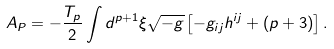<formula> <loc_0><loc_0><loc_500><loc_500>A _ { P } = - \frac { T _ { p } } { 2 } \int d ^ { p + 1 } { \xi } \sqrt { - g } \left [ - g _ { i j } h ^ { i j } + ( p + 3 ) \right ] .</formula> 